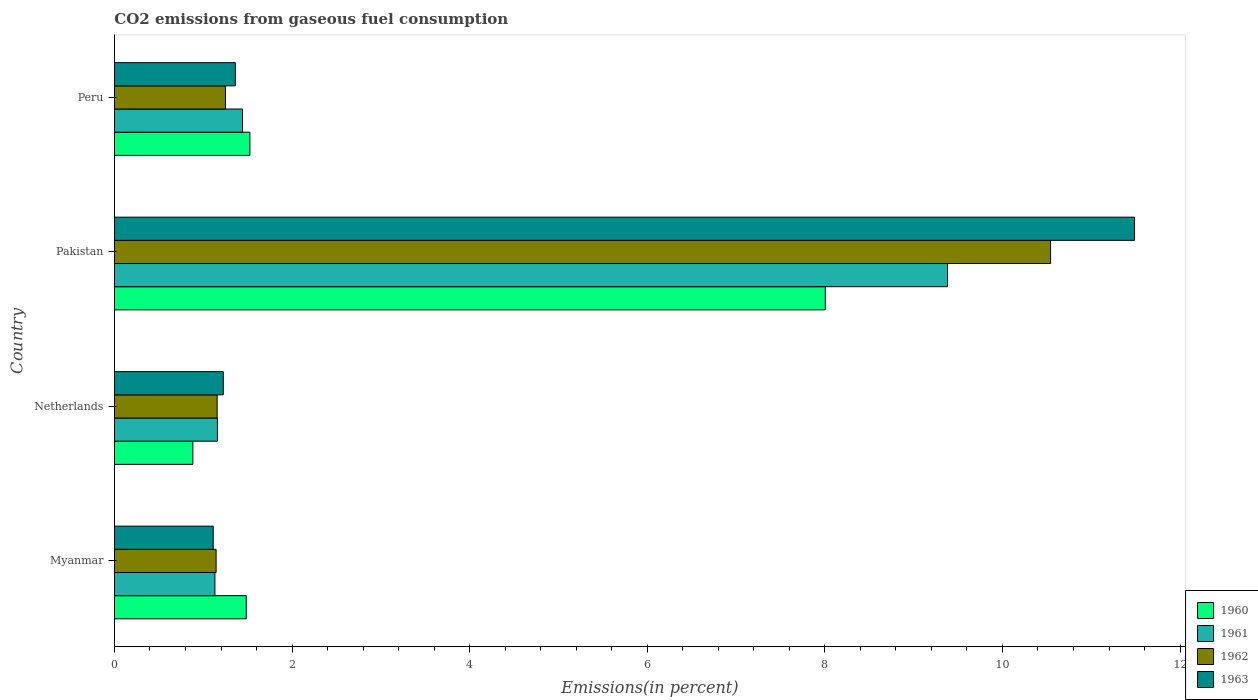Are the number of bars per tick equal to the number of legend labels?
Give a very brief answer. Yes. Are the number of bars on each tick of the Y-axis equal?
Your response must be concise. Yes. How many bars are there on the 1st tick from the bottom?
Provide a succinct answer. 4. In how many cases, is the number of bars for a given country not equal to the number of legend labels?
Keep it short and to the point. 0. What is the total CO2 emitted in 1962 in Peru?
Ensure brevity in your answer.  1.25. Across all countries, what is the maximum total CO2 emitted in 1963?
Give a very brief answer. 11.49. Across all countries, what is the minimum total CO2 emitted in 1960?
Ensure brevity in your answer.  0.88. In which country was the total CO2 emitted in 1961 maximum?
Provide a short and direct response. Pakistan. In which country was the total CO2 emitted in 1962 minimum?
Ensure brevity in your answer.  Myanmar. What is the total total CO2 emitted in 1963 in the graph?
Give a very brief answer. 15.19. What is the difference between the total CO2 emitted in 1962 in Netherlands and that in Peru?
Ensure brevity in your answer.  -0.09. What is the difference between the total CO2 emitted in 1961 in Myanmar and the total CO2 emitted in 1963 in Netherlands?
Provide a short and direct response. -0.09. What is the average total CO2 emitted in 1961 per country?
Your response must be concise. 3.28. What is the difference between the total CO2 emitted in 1962 and total CO2 emitted in 1961 in Peru?
Offer a terse response. -0.19. In how many countries, is the total CO2 emitted in 1960 greater than 1.2000000000000002 %?
Provide a short and direct response. 3. What is the ratio of the total CO2 emitted in 1961 in Pakistan to that in Peru?
Provide a succinct answer. 6.5. Is the total CO2 emitted in 1963 in Myanmar less than that in Pakistan?
Make the answer very short. Yes. Is the difference between the total CO2 emitted in 1962 in Netherlands and Pakistan greater than the difference between the total CO2 emitted in 1961 in Netherlands and Pakistan?
Your answer should be compact. No. What is the difference between the highest and the second highest total CO2 emitted in 1960?
Make the answer very short. 6.48. What is the difference between the highest and the lowest total CO2 emitted in 1961?
Offer a terse response. 8.25. How many bars are there?
Ensure brevity in your answer.  16. Are all the bars in the graph horizontal?
Provide a short and direct response. Yes. How many countries are there in the graph?
Give a very brief answer. 4. Does the graph contain grids?
Provide a short and direct response. No. How many legend labels are there?
Offer a very short reply. 4. How are the legend labels stacked?
Provide a succinct answer. Vertical. What is the title of the graph?
Keep it short and to the point. CO2 emissions from gaseous fuel consumption. Does "1980" appear as one of the legend labels in the graph?
Offer a terse response. No. What is the label or title of the X-axis?
Provide a short and direct response. Emissions(in percent). What is the label or title of the Y-axis?
Provide a succinct answer. Country. What is the Emissions(in percent) in 1960 in Myanmar?
Keep it short and to the point. 1.48. What is the Emissions(in percent) in 1961 in Myanmar?
Provide a short and direct response. 1.13. What is the Emissions(in percent) in 1962 in Myanmar?
Keep it short and to the point. 1.15. What is the Emissions(in percent) in 1963 in Myanmar?
Offer a very short reply. 1.11. What is the Emissions(in percent) of 1960 in Netherlands?
Ensure brevity in your answer.  0.88. What is the Emissions(in percent) in 1961 in Netherlands?
Your response must be concise. 1.16. What is the Emissions(in percent) in 1962 in Netherlands?
Offer a terse response. 1.16. What is the Emissions(in percent) of 1963 in Netherlands?
Offer a terse response. 1.23. What is the Emissions(in percent) of 1960 in Pakistan?
Keep it short and to the point. 8.01. What is the Emissions(in percent) of 1961 in Pakistan?
Your answer should be compact. 9.38. What is the Emissions(in percent) in 1962 in Pakistan?
Give a very brief answer. 10.54. What is the Emissions(in percent) of 1963 in Pakistan?
Your response must be concise. 11.49. What is the Emissions(in percent) in 1960 in Peru?
Offer a terse response. 1.53. What is the Emissions(in percent) in 1961 in Peru?
Your answer should be very brief. 1.44. What is the Emissions(in percent) in 1962 in Peru?
Keep it short and to the point. 1.25. What is the Emissions(in percent) in 1963 in Peru?
Make the answer very short. 1.36. Across all countries, what is the maximum Emissions(in percent) of 1960?
Offer a very short reply. 8.01. Across all countries, what is the maximum Emissions(in percent) in 1961?
Make the answer very short. 9.38. Across all countries, what is the maximum Emissions(in percent) of 1962?
Your response must be concise. 10.54. Across all countries, what is the maximum Emissions(in percent) of 1963?
Ensure brevity in your answer.  11.49. Across all countries, what is the minimum Emissions(in percent) of 1960?
Keep it short and to the point. 0.88. Across all countries, what is the minimum Emissions(in percent) of 1961?
Give a very brief answer. 1.13. Across all countries, what is the minimum Emissions(in percent) of 1962?
Provide a succinct answer. 1.15. Across all countries, what is the minimum Emissions(in percent) of 1963?
Give a very brief answer. 1.11. What is the total Emissions(in percent) in 1960 in the graph?
Your response must be concise. 11.9. What is the total Emissions(in percent) of 1961 in the graph?
Give a very brief answer. 13.12. What is the total Emissions(in percent) in 1962 in the graph?
Give a very brief answer. 14.09. What is the total Emissions(in percent) in 1963 in the graph?
Your answer should be compact. 15.19. What is the difference between the Emissions(in percent) of 1960 in Myanmar and that in Netherlands?
Your answer should be compact. 0.6. What is the difference between the Emissions(in percent) in 1961 in Myanmar and that in Netherlands?
Provide a succinct answer. -0.03. What is the difference between the Emissions(in percent) of 1962 in Myanmar and that in Netherlands?
Offer a very short reply. -0.01. What is the difference between the Emissions(in percent) in 1963 in Myanmar and that in Netherlands?
Keep it short and to the point. -0.11. What is the difference between the Emissions(in percent) in 1960 in Myanmar and that in Pakistan?
Provide a succinct answer. -6.52. What is the difference between the Emissions(in percent) in 1961 in Myanmar and that in Pakistan?
Provide a succinct answer. -8.25. What is the difference between the Emissions(in percent) in 1962 in Myanmar and that in Pakistan?
Offer a terse response. -9.4. What is the difference between the Emissions(in percent) of 1963 in Myanmar and that in Pakistan?
Your answer should be very brief. -10.37. What is the difference between the Emissions(in percent) of 1960 in Myanmar and that in Peru?
Give a very brief answer. -0.04. What is the difference between the Emissions(in percent) of 1961 in Myanmar and that in Peru?
Give a very brief answer. -0.31. What is the difference between the Emissions(in percent) in 1962 in Myanmar and that in Peru?
Make the answer very short. -0.11. What is the difference between the Emissions(in percent) of 1963 in Myanmar and that in Peru?
Ensure brevity in your answer.  -0.25. What is the difference between the Emissions(in percent) in 1960 in Netherlands and that in Pakistan?
Your answer should be compact. -7.12. What is the difference between the Emissions(in percent) of 1961 in Netherlands and that in Pakistan?
Offer a very short reply. -8.22. What is the difference between the Emissions(in percent) of 1962 in Netherlands and that in Pakistan?
Give a very brief answer. -9.38. What is the difference between the Emissions(in percent) in 1963 in Netherlands and that in Pakistan?
Your answer should be compact. -10.26. What is the difference between the Emissions(in percent) of 1960 in Netherlands and that in Peru?
Offer a very short reply. -0.64. What is the difference between the Emissions(in percent) of 1961 in Netherlands and that in Peru?
Your answer should be compact. -0.28. What is the difference between the Emissions(in percent) of 1962 in Netherlands and that in Peru?
Ensure brevity in your answer.  -0.09. What is the difference between the Emissions(in percent) of 1963 in Netherlands and that in Peru?
Make the answer very short. -0.14. What is the difference between the Emissions(in percent) in 1960 in Pakistan and that in Peru?
Your answer should be compact. 6.48. What is the difference between the Emissions(in percent) in 1961 in Pakistan and that in Peru?
Provide a succinct answer. 7.94. What is the difference between the Emissions(in percent) of 1962 in Pakistan and that in Peru?
Offer a very short reply. 9.29. What is the difference between the Emissions(in percent) of 1963 in Pakistan and that in Peru?
Provide a short and direct response. 10.13. What is the difference between the Emissions(in percent) of 1960 in Myanmar and the Emissions(in percent) of 1961 in Netherlands?
Provide a short and direct response. 0.32. What is the difference between the Emissions(in percent) in 1960 in Myanmar and the Emissions(in percent) in 1962 in Netherlands?
Your response must be concise. 0.33. What is the difference between the Emissions(in percent) of 1960 in Myanmar and the Emissions(in percent) of 1963 in Netherlands?
Give a very brief answer. 0.26. What is the difference between the Emissions(in percent) of 1961 in Myanmar and the Emissions(in percent) of 1962 in Netherlands?
Offer a very short reply. -0.03. What is the difference between the Emissions(in percent) in 1961 in Myanmar and the Emissions(in percent) in 1963 in Netherlands?
Your answer should be very brief. -0.09. What is the difference between the Emissions(in percent) in 1962 in Myanmar and the Emissions(in percent) in 1963 in Netherlands?
Ensure brevity in your answer.  -0.08. What is the difference between the Emissions(in percent) in 1960 in Myanmar and the Emissions(in percent) in 1961 in Pakistan?
Give a very brief answer. -7.9. What is the difference between the Emissions(in percent) in 1960 in Myanmar and the Emissions(in percent) in 1962 in Pakistan?
Provide a succinct answer. -9.06. What is the difference between the Emissions(in percent) in 1960 in Myanmar and the Emissions(in percent) in 1963 in Pakistan?
Provide a short and direct response. -10. What is the difference between the Emissions(in percent) of 1961 in Myanmar and the Emissions(in percent) of 1962 in Pakistan?
Make the answer very short. -9.41. What is the difference between the Emissions(in percent) of 1961 in Myanmar and the Emissions(in percent) of 1963 in Pakistan?
Make the answer very short. -10.36. What is the difference between the Emissions(in percent) of 1962 in Myanmar and the Emissions(in percent) of 1963 in Pakistan?
Give a very brief answer. -10.34. What is the difference between the Emissions(in percent) in 1960 in Myanmar and the Emissions(in percent) in 1961 in Peru?
Offer a terse response. 0.04. What is the difference between the Emissions(in percent) in 1960 in Myanmar and the Emissions(in percent) in 1962 in Peru?
Make the answer very short. 0.23. What is the difference between the Emissions(in percent) of 1960 in Myanmar and the Emissions(in percent) of 1963 in Peru?
Provide a short and direct response. 0.12. What is the difference between the Emissions(in percent) of 1961 in Myanmar and the Emissions(in percent) of 1962 in Peru?
Provide a succinct answer. -0.12. What is the difference between the Emissions(in percent) in 1961 in Myanmar and the Emissions(in percent) in 1963 in Peru?
Make the answer very short. -0.23. What is the difference between the Emissions(in percent) of 1962 in Myanmar and the Emissions(in percent) of 1963 in Peru?
Ensure brevity in your answer.  -0.22. What is the difference between the Emissions(in percent) in 1960 in Netherlands and the Emissions(in percent) in 1961 in Pakistan?
Provide a succinct answer. -8.5. What is the difference between the Emissions(in percent) in 1960 in Netherlands and the Emissions(in percent) in 1962 in Pakistan?
Your response must be concise. -9.66. What is the difference between the Emissions(in percent) of 1960 in Netherlands and the Emissions(in percent) of 1963 in Pakistan?
Make the answer very short. -10.6. What is the difference between the Emissions(in percent) of 1961 in Netherlands and the Emissions(in percent) of 1962 in Pakistan?
Offer a terse response. -9.38. What is the difference between the Emissions(in percent) in 1961 in Netherlands and the Emissions(in percent) in 1963 in Pakistan?
Your response must be concise. -10.33. What is the difference between the Emissions(in percent) of 1962 in Netherlands and the Emissions(in percent) of 1963 in Pakistan?
Your answer should be compact. -10.33. What is the difference between the Emissions(in percent) of 1960 in Netherlands and the Emissions(in percent) of 1961 in Peru?
Your answer should be very brief. -0.56. What is the difference between the Emissions(in percent) of 1960 in Netherlands and the Emissions(in percent) of 1962 in Peru?
Make the answer very short. -0.37. What is the difference between the Emissions(in percent) of 1960 in Netherlands and the Emissions(in percent) of 1963 in Peru?
Provide a succinct answer. -0.48. What is the difference between the Emissions(in percent) in 1961 in Netherlands and the Emissions(in percent) in 1962 in Peru?
Your answer should be compact. -0.09. What is the difference between the Emissions(in percent) in 1961 in Netherlands and the Emissions(in percent) in 1963 in Peru?
Your answer should be very brief. -0.2. What is the difference between the Emissions(in percent) of 1962 in Netherlands and the Emissions(in percent) of 1963 in Peru?
Keep it short and to the point. -0.2. What is the difference between the Emissions(in percent) in 1960 in Pakistan and the Emissions(in percent) in 1961 in Peru?
Offer a very short reply. 6.56. What is the difference between the Emissions(in percent) in 1960 in Pakistan and the Emissions(in percent) in 1962 in Peru?
Keep it short and to the point. 6.75. What is the difference between the Emissions(in percent) of 1960 in Pakistan and the Emissions(in percent) of 1963 in Peru?
Ensure brevity in your answer.  6.64. What is the difference between the Emissions(in percent) in 1961 in Pakistan and the Emissions(in percent) in 1962 in Peru?
Your response must be concise. 8.13. What is the difference between the Emissions(in percent) in 1961 in Pakistan and the Emissions(in percent) in 1963 in Peru?
Make the answer very short. 8.02. What is the difference between the Emissions(in percent) of 1962 in Pakistan and the Emissions(in percent) of 1963 in Peru?
Offer a very short reply. 9.18. What is the average Emissions(in percent) of 1960 per country?
Provide a succinct answer. 2.97. What is the average Emissions(in percent) in 1961 per country?
Provide a short and direct response. 3.28. What is the average Emissions(in percent) of 1962 per country?
Your answer should be compact. 3.52. What is the average Emissions(in percent) of 1963 per country?
Your response must be concise. 3.8. What is the difference between the Emissions(in percent) in 1960 and Emissions(in percent) in 1961 in Myanmar?
Give a very brief answer. 0.35. What is the difference between the Emissions(in percent) of 1960 and Emissions(in percent) of 1962 in Myanmar?
Make the answer very short. 0.34. What is the difference between the Emissions(in percent) in 1960 and Emissions(in percent) in 1963 in Myanmar?
Offer a terse response. 0.37. What is the difference between the Emissions(in percent) of 1961 and Emissions(in percent) of 1962 in Myanmar?
Ensure brevity in your answer.  -0.01. What is the difference between the Emissions(in percent) of 1961 and Emissions(in percent) of 1963 in Myanmar?
Ensure brevity in your answer.  0.02. What is the difference between the Emissions(in percent) in 1962 and Emissions(in percent) in 1963 in Myanmar?
Provide a short and direct response. 0.03. What is the difference between the Emissions(in percent) in 1960 and Emissions(in percent) in 1961 in Netherlands?
Provide a succinct answer. -0.28. What is the difference between the Emissions(in percent) in 1960 and Emissions(in percent) in 1962 in Netherlands?
Your response must be concise. -0.27. What is the difference between the Emissions(in percent) of 1960 and Emissions(in percent) of 1963 in Netherlands?
Ensure brevity in your answer.  -0.34. What is the difference between the Emissions(in percent) in 1961 and Emissions(in percent) in 1962 in Netherlands?
Give a very brief answer. 0. What is the difference between the Emissions(in percent) in 1961 and Emissions(in percent) in 1963 in Netherlands?
Make the answer very short. -0.07. What is the difference between the Emissions(in percent) of 1962 and Emissions(in percent) of 1963 in Netherlands?
Your answer should be very brief. -0.07. What is the difference between the Emissions(in percent) of 1960 and Emissions(in percent) of 1961 in Pakistan?
Provide a succinct answer. -1.38. What is the difference between the Emissions(in percent) of 1960 and Emissions(in percent) of 1962 in Pakistan?
Your answer should be compact. -2.54. What is the difference between the Emissions(in percent) of 1960 and Emissions(in percent) of 1963 in Pakistan?
Give a very brief answer. -3.48. What is the difference between the Emissions(in percent) in 1961 and Emissions(in percent) in 1962 in Pakistan?
Make the answer very short. -1.16. What is the difference between the Emissions(in percent) of 1961 and Emissions(in percent) of 1963 in Pakistan?
Offer a terse response. -2.11. What is the difference between the Emissions(in percent) in 1962 and Emissions(in percent) in 1963 in Pakistan?
Keep it short and to the point. -0.95. What is the difference between the Emissions(in percent) in 1960 and Emissions(in percent) in 1961 in Peru?
Provide a succinct answer. 0.08. What is the difference between the Emissions(in percent) of 1960 and Emissions(in percent) of 1962 in Peru?
Provide a short and direct response. 0.27. What is the difference between the Emissions(in percent) in 1960 and Emissions(in percent) in 1963 in Peru?
Your answer should be very brief. 0.16. What is the difference between the Emissions(in percent) of 1961 and Emissions(in percent) of 1962 in Peru?
Ensure brevity in your answer.  0.19. What is the difference between the Emissions(in percent) of 1961 and Emissions(in percent) of 1963 in Peru?
Ensure brevity in your answer.  0.08. What is the difference between the Emissions(in percent) in 1962 and Emissions(in percent) in 1963 in Peru?
Keep it short and to the point. -0.11. What is the ratio of the Emissions(in percent) in 1960 in Myanmar to that in Netherlands?
Offer a terse response. 1.68. What is the ratio of the Emissions(in percent) in 1961 in Myanmar to that in Netherlands?
Provide a succinct answer. 0.98. What is the ratio of the Emissions(in percent) in 1963 in Myanmar to that in Netherlands?
Give a very brief answer. 0.91. What is the ratio of the Emissions(in percent) in 1960 in Myanmar to that in Pakistan?
Keep it short and to the point. 0.19. What is the ratio of the Emissions(in percent) in 1961 in Myanmar to that in Pakistan?
Provide a short and direct response. 0.12. What is the ratio of the Emissions(in percent) of 1962 in Myanmar to that in Pakistan?
Your response must be concise. 0.11. What is the ratio of the Emissions(in percent) in 1963 in Myanmar to that in Pakistan?
Give a very brief answer. 0.1. What is the ratio of the Emissions(in percent) in 1960 in Myanmar to that in Peru?
Ensure brevity in your answer.  0.97. What is the ratio of the Emissions(in percent) of 1961 in Myanmar to that in Peru?
Ensure brevity in your answer.  0.78. What is the ratio of the Emissions(in percent) of 1962 in Myanmar to that in Peru?
Offer a very short reply. 0.92. What is the ratio of the Emissions(in percent) in 1963 in Myanmar to that in Peru?
Make the answer very short. 0.82. What is the ratio of the Emissions(in percent) in 1960 in Netherlands to that in Pakistan?
Provide a short and direct response. 0.11. What is the ratio of the Emissions(in percent) in 1961 in Netherlands to that in Pakistan?
Ensure brevity in your answer.  0.12. What is the ratio of the Emissions(in percent) of 1962 in Netherlands to that in Pakistan?
Make the answer very short. 0.11. What is the ratio of the Emissions(in percent) of 1963 in Netherlands to that in Pakistan?
Your answer should be compact. 0.11. What is the ratio of the Emissions(in percent) in 1960 in Netherlands to that in Peru?
Give a very brief answer. 0.58. What is the ratio of the Emissions(in percent) of 1961 in Netherlands to that in Peru?
Your answer should be very brief. 0.8. What is the ratio of the Emissions(in percent) in 1962 in Netherlands to that in Peru?
Provide a succinct answer. 0.93. What is the ratio of the Emissions(in percent) in 1963 in Netherlands to that in Peru?
Provide a short and direct response. 0.9. What is the ratio of the Emissions(in percent) of 1960 in Pakistan to that in Peru?
Offer a very short reply. 5.25. What is the ratio of the Emissions(in percent) in 1961 in Pakistan to that in Peru?
Your answer should be very brief. 6.5. What is the ratio of the Emissions(in percent) in 1962 in Pakistan to that in Peru?
Give a very brief answer. 8.43. What is the ratio of the Emissions(in percent) of 1963 in Pakistan to that in Peru?
Provide a short and direct response. 8.44. What is the difference between the highest and the second highest Emissions(in percent) of 1960?
Provide a succinct answer. 6.48. What is the difference between the highest and the second highest Emissions(in percent) of 1961?
Your response must be concise. 7.94. What is the difference between the highest and the second highest Emissions(in percent) in 1962?
Offer a terse response. 9.29. What is the difference between the highest and the second highest Emissions(in percent) in 1963?
Your answer should be very brief. 10.13. What is the difference between the highest and the lowest Emissions(in percent) in 1960?
Your response must be concise. 7.12. What is the difference between the highest and the lowest Emissions(in percent) in 1961?
Keep it short and to the point. 8.25. What is the difference between the highest and the lowest Emissions(in percent) in 1962?
Offer a terse response. 9.4. What is the difference between the highest and the lowest Emissions(in percent) of 1963?
Give a very brief answer. 10.37. 